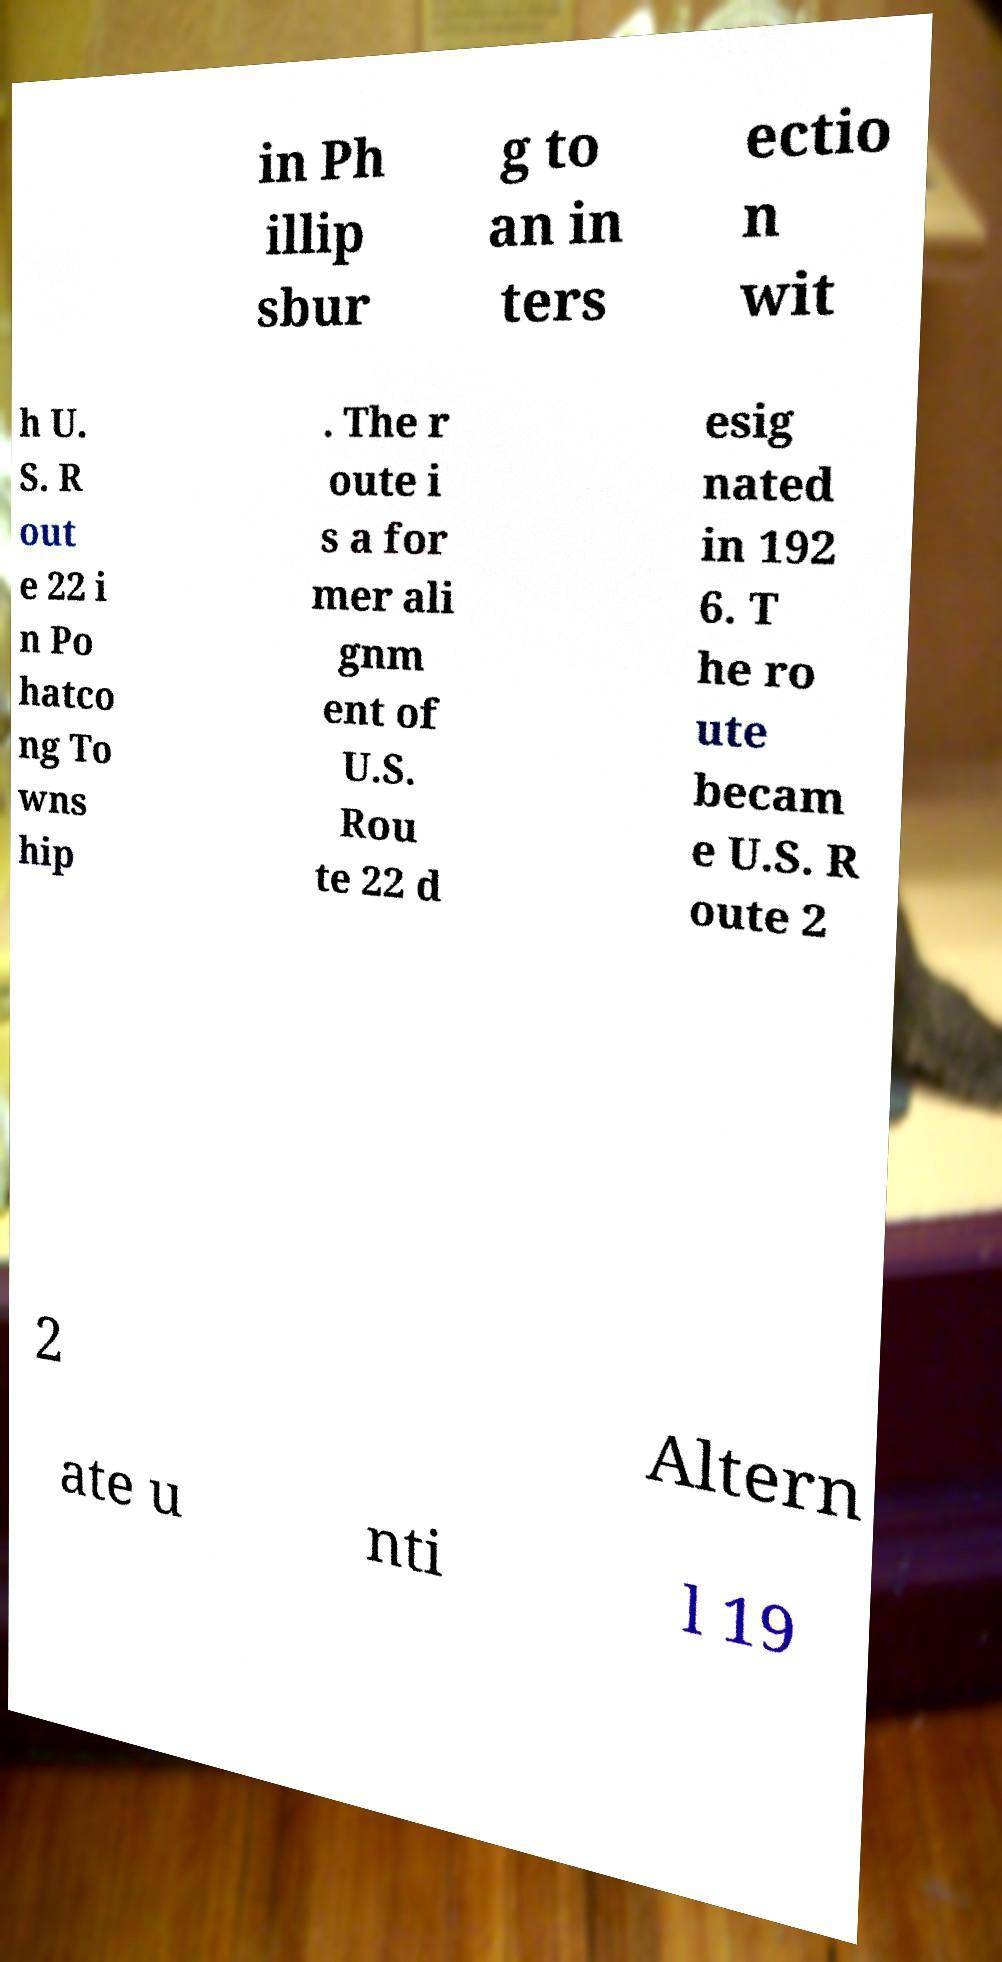What messages or text are displayed in this image? I need them in a readable, typed format. in Ph illip sbur g to an in ters ectio n wit h U. S. R out e 22 i n Po hatco ng To wns hip . The r oute i s a for mer ali gnm ent of U.S. Rou te 22 d esig nated in 192 6. T he ro ute becam e U.S. R oute 2 2 Altern ate u nti l 19 